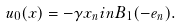Convert formula to latex. <formula><loc_0><loc_0><loc_500><loc_500>u _ { 0 } ( x ) = - \gamma x _ { n } { i n } B _ { 1 } ( - e _ { n } ) .</formula> 